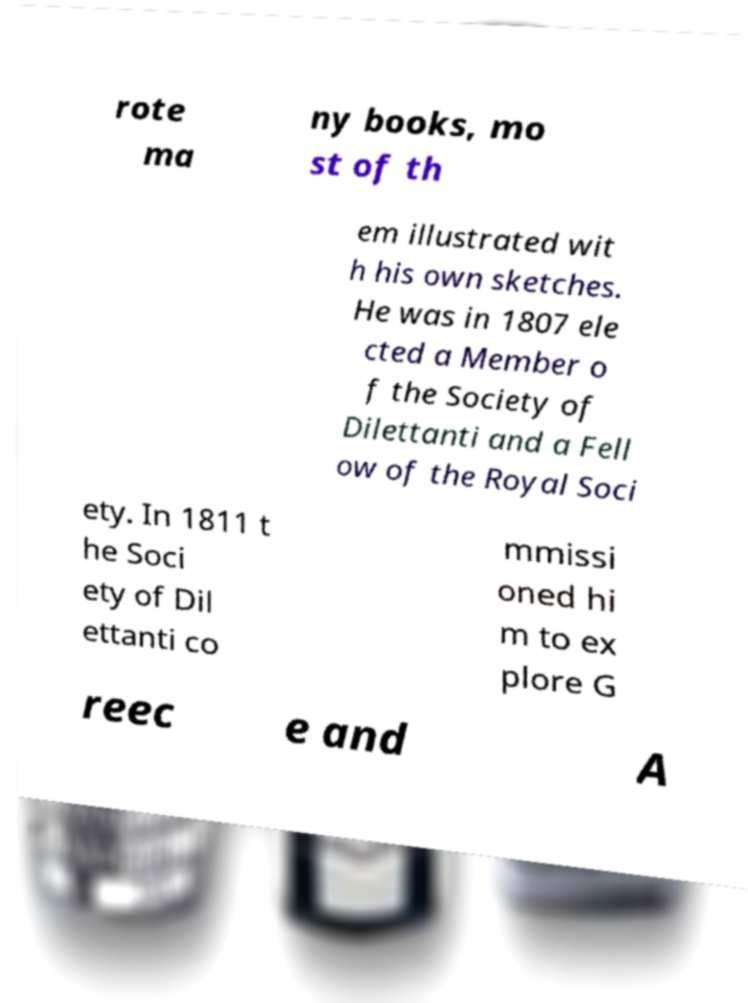Please read and relay the text visible in this image. What does it say? rote ma ny books, mo st of th em illustrated wit h his own sketches. He was in 1807 ele cted a Member o f the Society of Dilettanti and a Fell ow of the Royal Soci ety. In 1811 t he Soci ety of Dil ettanti co mmissi oned hi m to ex plore G reec e and A 